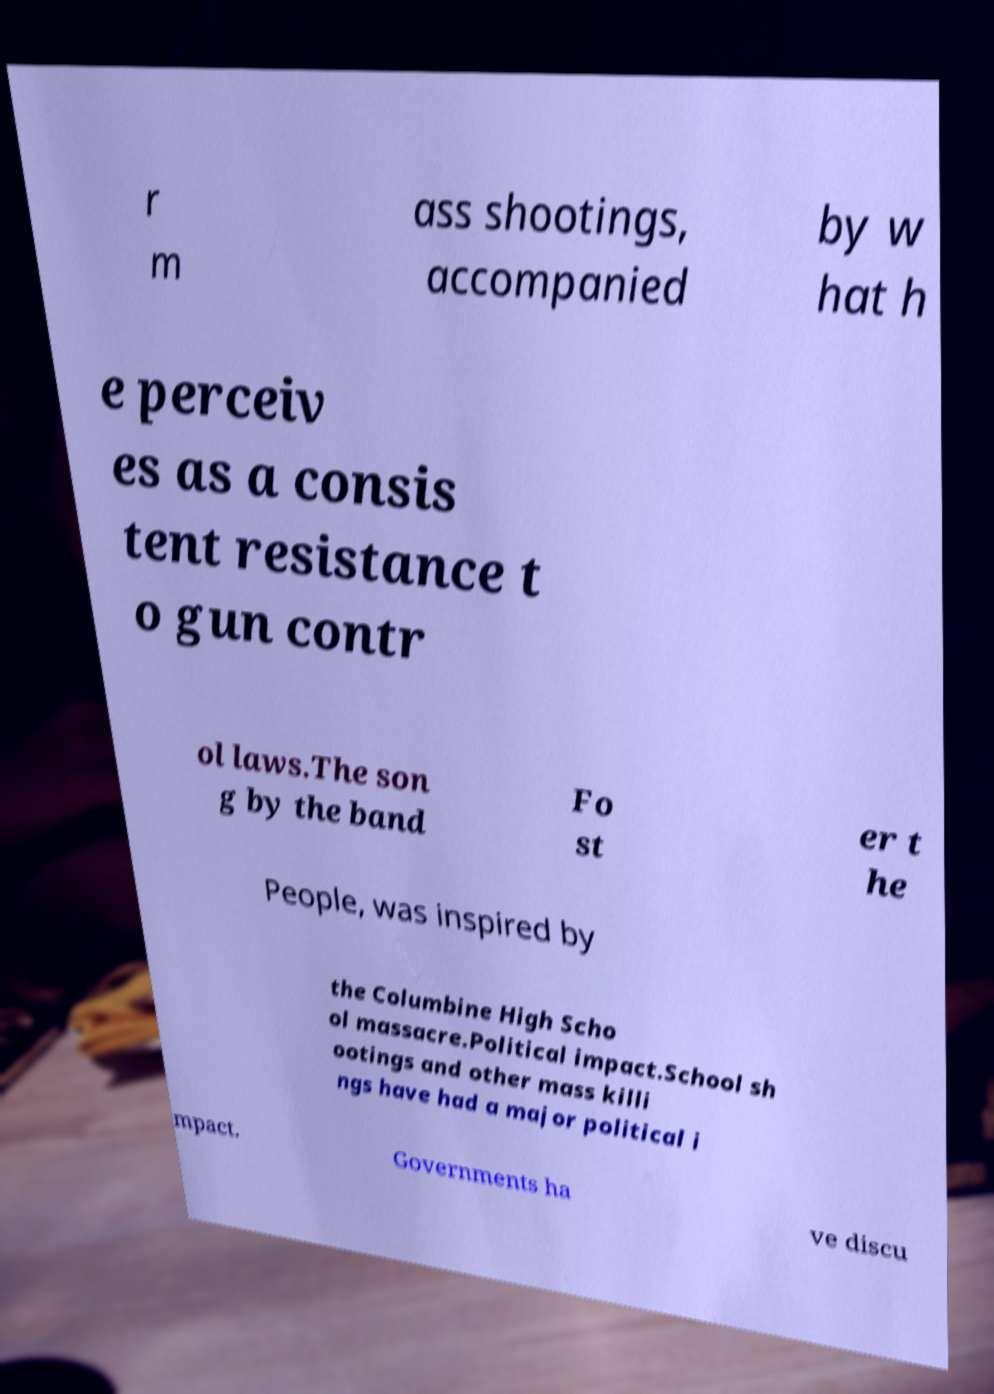For documentation purposes, I need the text within this image transcribed. Could you provide that? r m ass shootings, accompanied by w hat h e perceiv es as a consis tent resistance t o gun contr ol laws.The son g by the band Fo st er t he People, was inspired by the Columbine High Scho ol massacre.Political impact.School sh ootings and other mass killi ngs have had a major political i mpact. Governments ha ve discu 